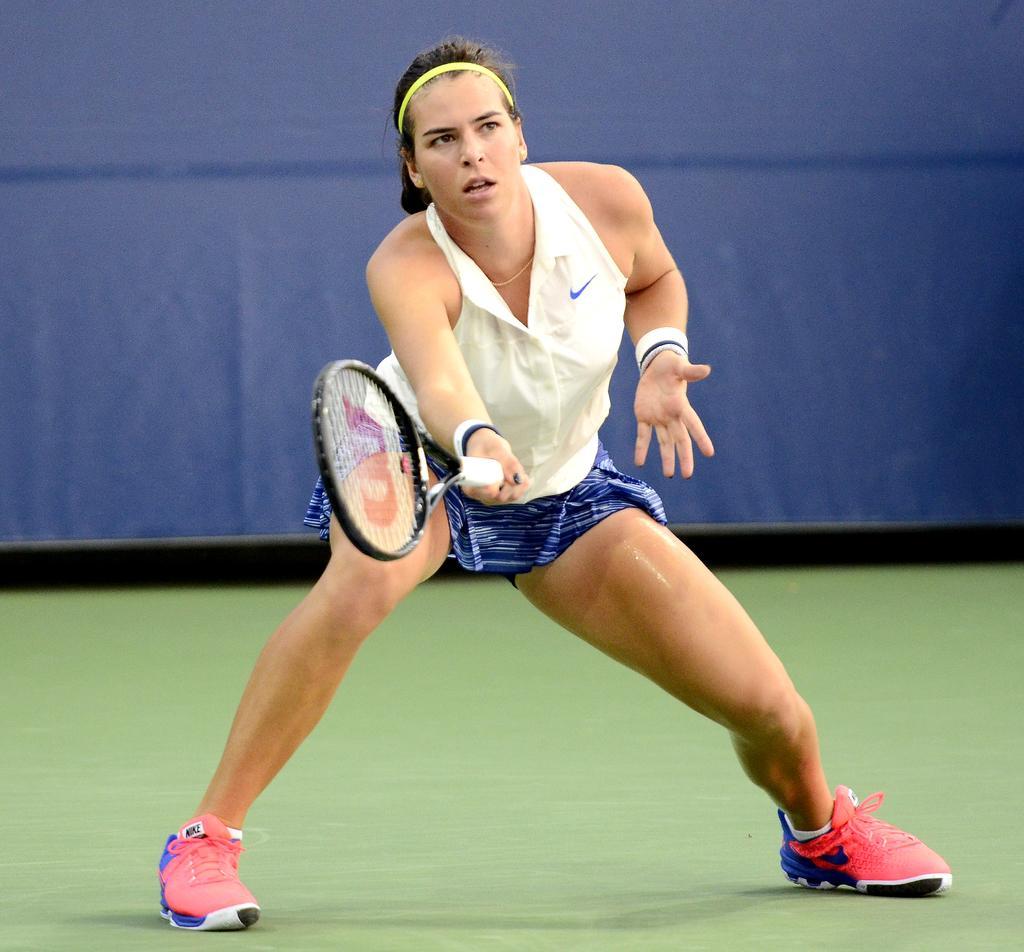Can you describe this image briefly? In this image I can see a person holding racket and she is on the ground. At the back there is a blue sheet. 